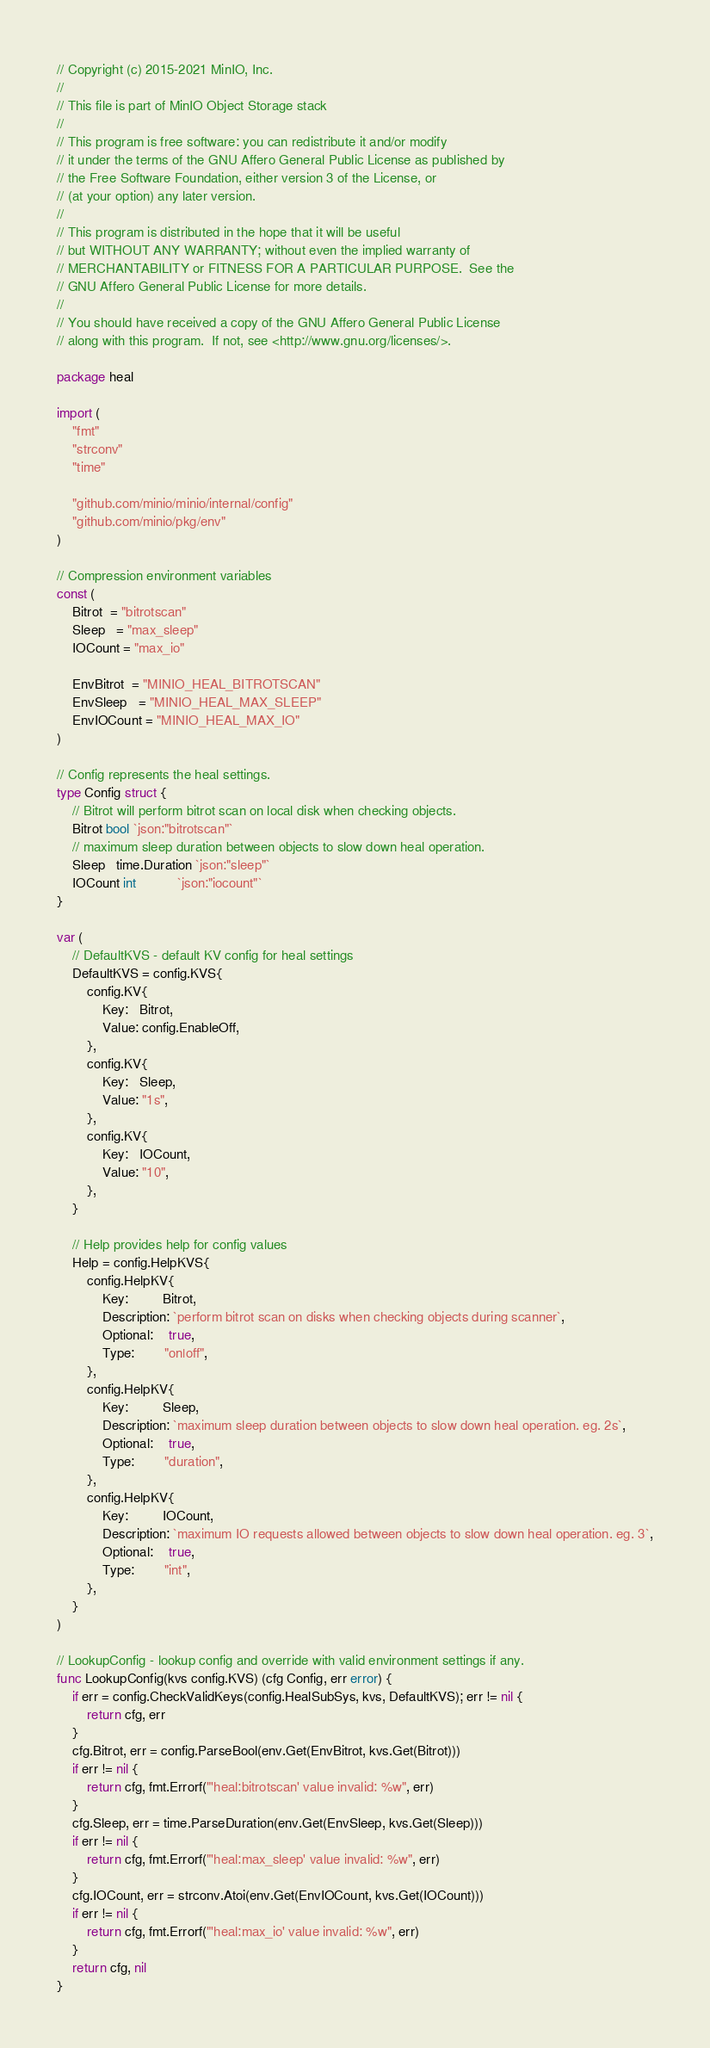Convert code to text. <code><loc_0><loc_0><loc_500><loc_500><_Go_>// Copyright (c) 2015-2021 MinIO, Inc.
//
// This file is part of MinIO Object Storage stack
//
// This program is free software: you can redistribute it and/or modify
// it under the terms of the GNU Affero General Public License as published by
// the Free Software Foundation, either version 3 of the License, or
// (at your option) any later version.
//
// This program is distributed in the hope that it will be useful
// but WITHOUT ANY WARRANTY; without even the implied warranty of
// MERCHANTABILITY or FITNESS FOR A PARTICULAR PURPOSE.  See the
// GNU Affero General Public License for more details.
//
// You should have received a copy of the GNU Affero General Public License
// along with this program.  If not, see <http://www.gnu.org/licenses/>.

package heal

import (
	"fmt"
	"strconv"
	"time"

	"github.com/minio/minio/internal/config"
	"github.com/minio/pkg/env"
)

// Compression environment variables
const (
	Bitrot  = "bitrotscan"
	Sleep   = "max_sleep"
	IOCount = "max_io"

	EnvBitrot  = "MINIO_HEAL_BITROTSCAN"
	EnvSleep   = "MINIO_HEAL_MAX_SLEEP"
	EnvIOCount = "MINIO_HEAL_MAX_IO"
)

// Config represents the heal settings.
type Config struct {
	// Bitrot will perform bitrot scan on local disk when checking objects.
	Bitrot bool `json:"bitrotscan"`
	// maximum sleep duration between objects to slow down heal operation.
	Sleep   time.Duration `json:"sleep"`
	IOCount int           `json:"iocount"`
}

var (
	// DefaultKVS - default KV config for heal settings
	DefaultKVS = config.KVS{
		config.KV{
			Key:   Bitrot,
			Value: config.EnableOff,
		},
		config.KV{
			Key:   Sleep,
			Value: "1s",
		},
		config.KV{
			Key:   IOCount,
			Value: "10",
		},
	}

	// Help provides help for config values
	Help = config.HelpKVS{
		config.HelpKV{
			Key:         Bitrot,
			Description: `perform bitrot scan on disks when checking objects during scanner`,
			Optional:    true,
			Type:        "on|off",
		},
		config.HelpKV{
			Key:         Sleep,
			Description: `maximum sleep duration between objects to slow down heal operation. eg. 2s`,
			Optional:    true,
			Type:        "duration",
		},
		config.HelpKV{
			Key:         IOCount,
			Description: `maximum IO requests allowed between objects to slow down heal operation. eg. 3`,
			Optional:    true,
			Type:        "int",
		},
	}
)

// LookupConfig - lookup config and override with valid environment settings if any.
func LookupConfig(kvs config.KVS) (cfg Config, err error) {
	if err = config.CheckValidKeys(config.HealSubSys, kvs, DefaultKVS); err != nil {
		return cfg, err
	}
	cfg.Bitrot, err = config.ParseBool(env.Get(EnvBitrot, kvs.Get(Bitrot)))
	if err != nil {
		return cfg, fmt.Errorf("'heal:bitrotscan' value invalid: %w", err)
	}
	cfg.Sleep, err = time.ParseDuration(env.Get(EnvSleep, kvs.Get(Sleep)))
	if err != nil {
		return cfg, fmt.Errorf("'heal:max_sleep' value invalid: %w", err)
	}
	cfg.IOCount, err = strconv.Atoi(env.Get(EnvIOCount, kvs.Get(IOCount)))
	if err != nil {
		return cfg, fmt.Errorf("'heal:max_io' value invalid: %w", err)
	}
	return cfg, nil
}
</code> 